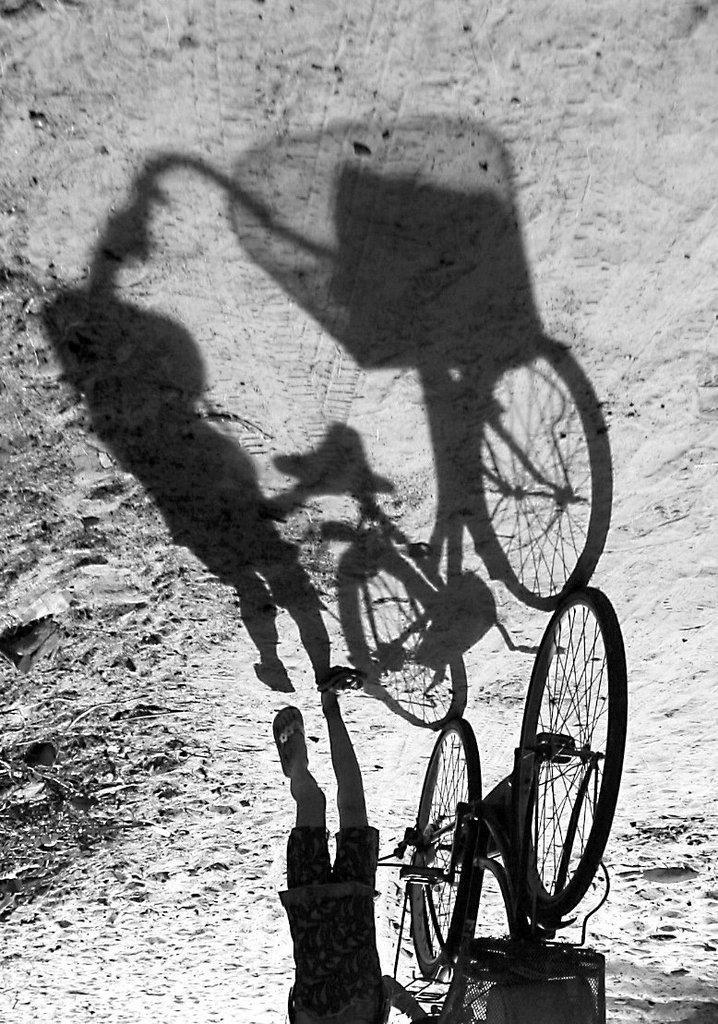Describe this image in one or two sentences. On the right side, there is a child holding a bicycle and walking on the road. On the road, there is a shadow of the bicycle and a child. 